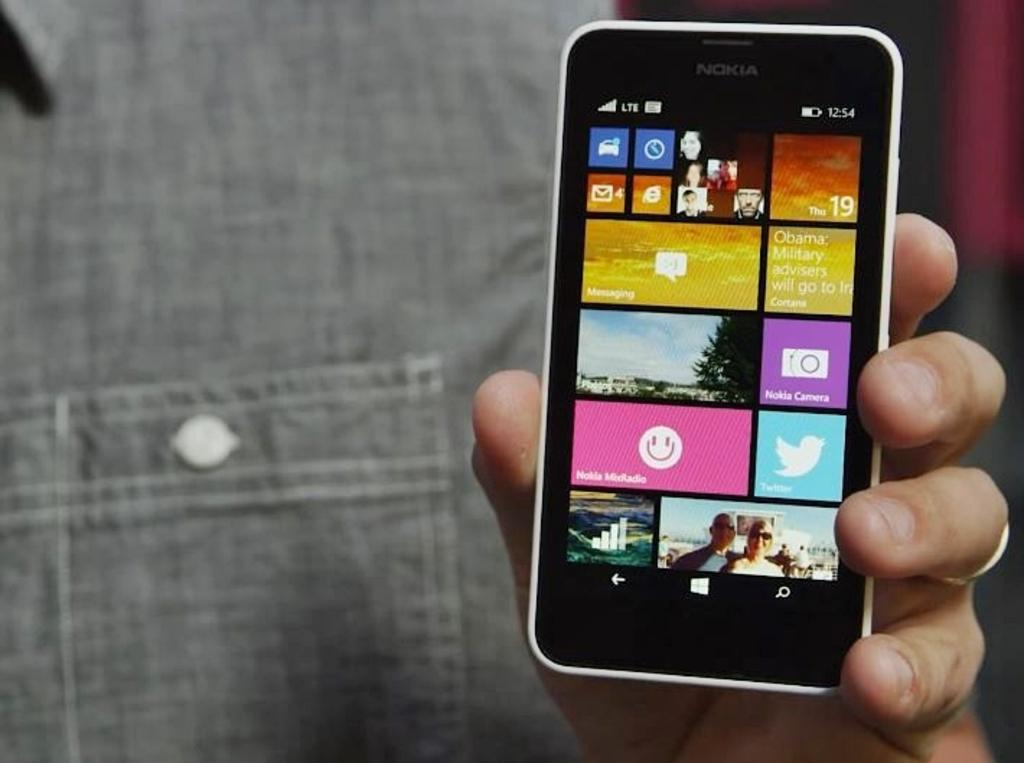<image>
Summarize the visual content of the image. A hand holding a smart phone that displays the time as 12.54. 